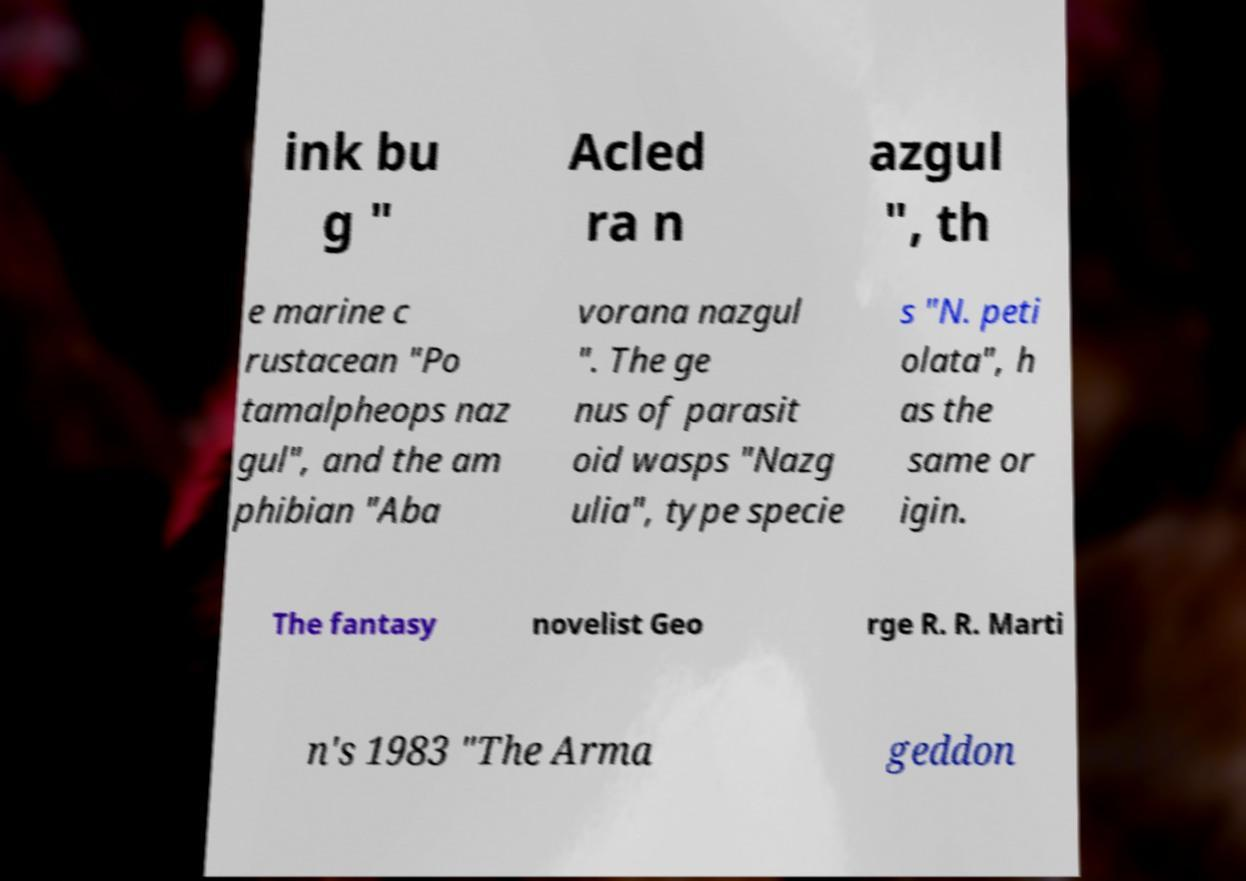Can you accurately transcribe the text from the provided image for me? ink bu g " Acled ra n azgul ", th e marine c rustacean "Po tamalpheops naz gul", and the am phibian "Aba vorana nazgul ". The ge nus of parasit oid wasps "Nazg ulia", type specie s "N. peti olata", h as the same or igin. The fantasy novelist Geo rge R. R. Marti n's 1983 "The Arma geddon 